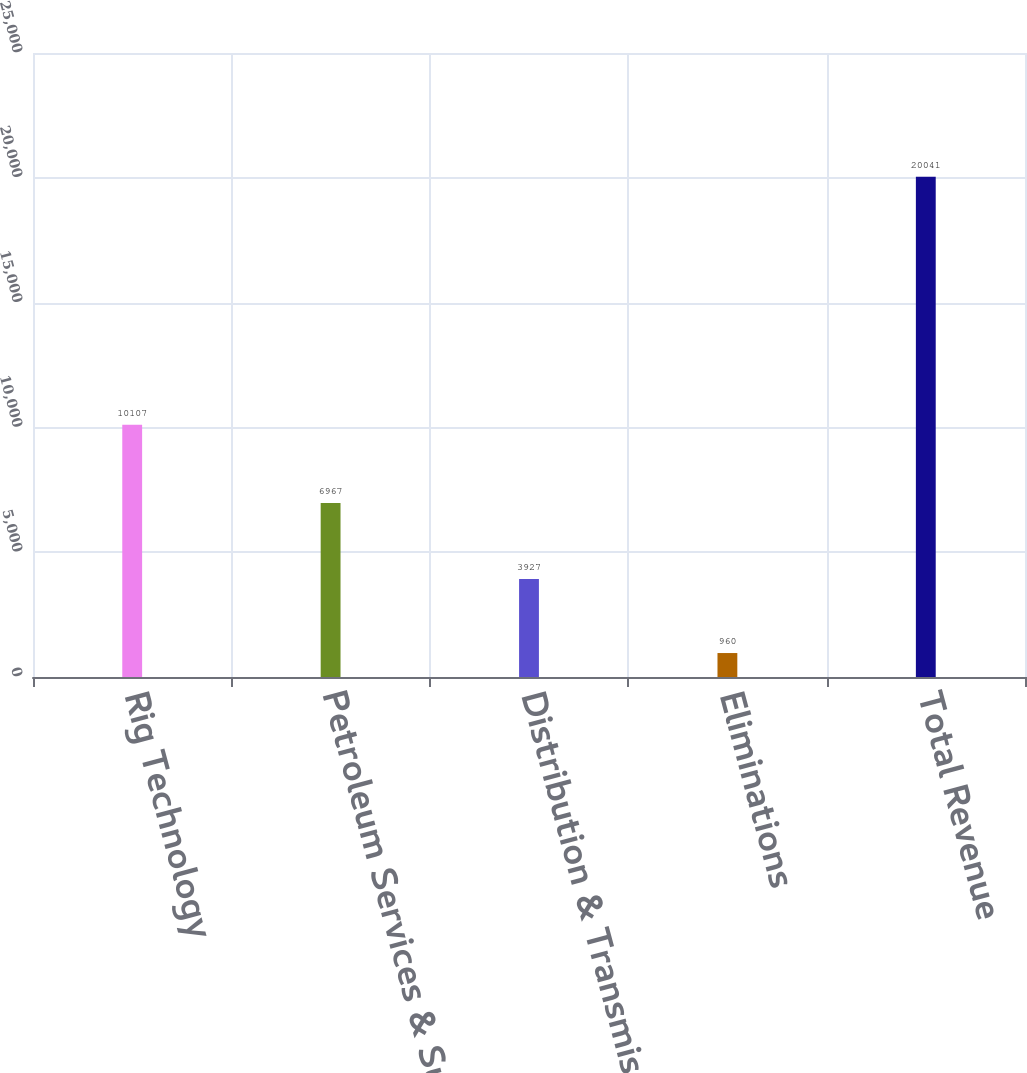Convert chart. <chart><loc_0><loc_0><loc_500><loc_500><bar_chart><fcel>Rig Technology<fcel>Petroleum Services & Supplies<fcel>Distribution & Transmission<fcel>Eliminations<fcel>Total Revenue<nl><fcel>10107<fcel>6967<fcel>3927<fcel>960<fcel>20041<nl></chart> 